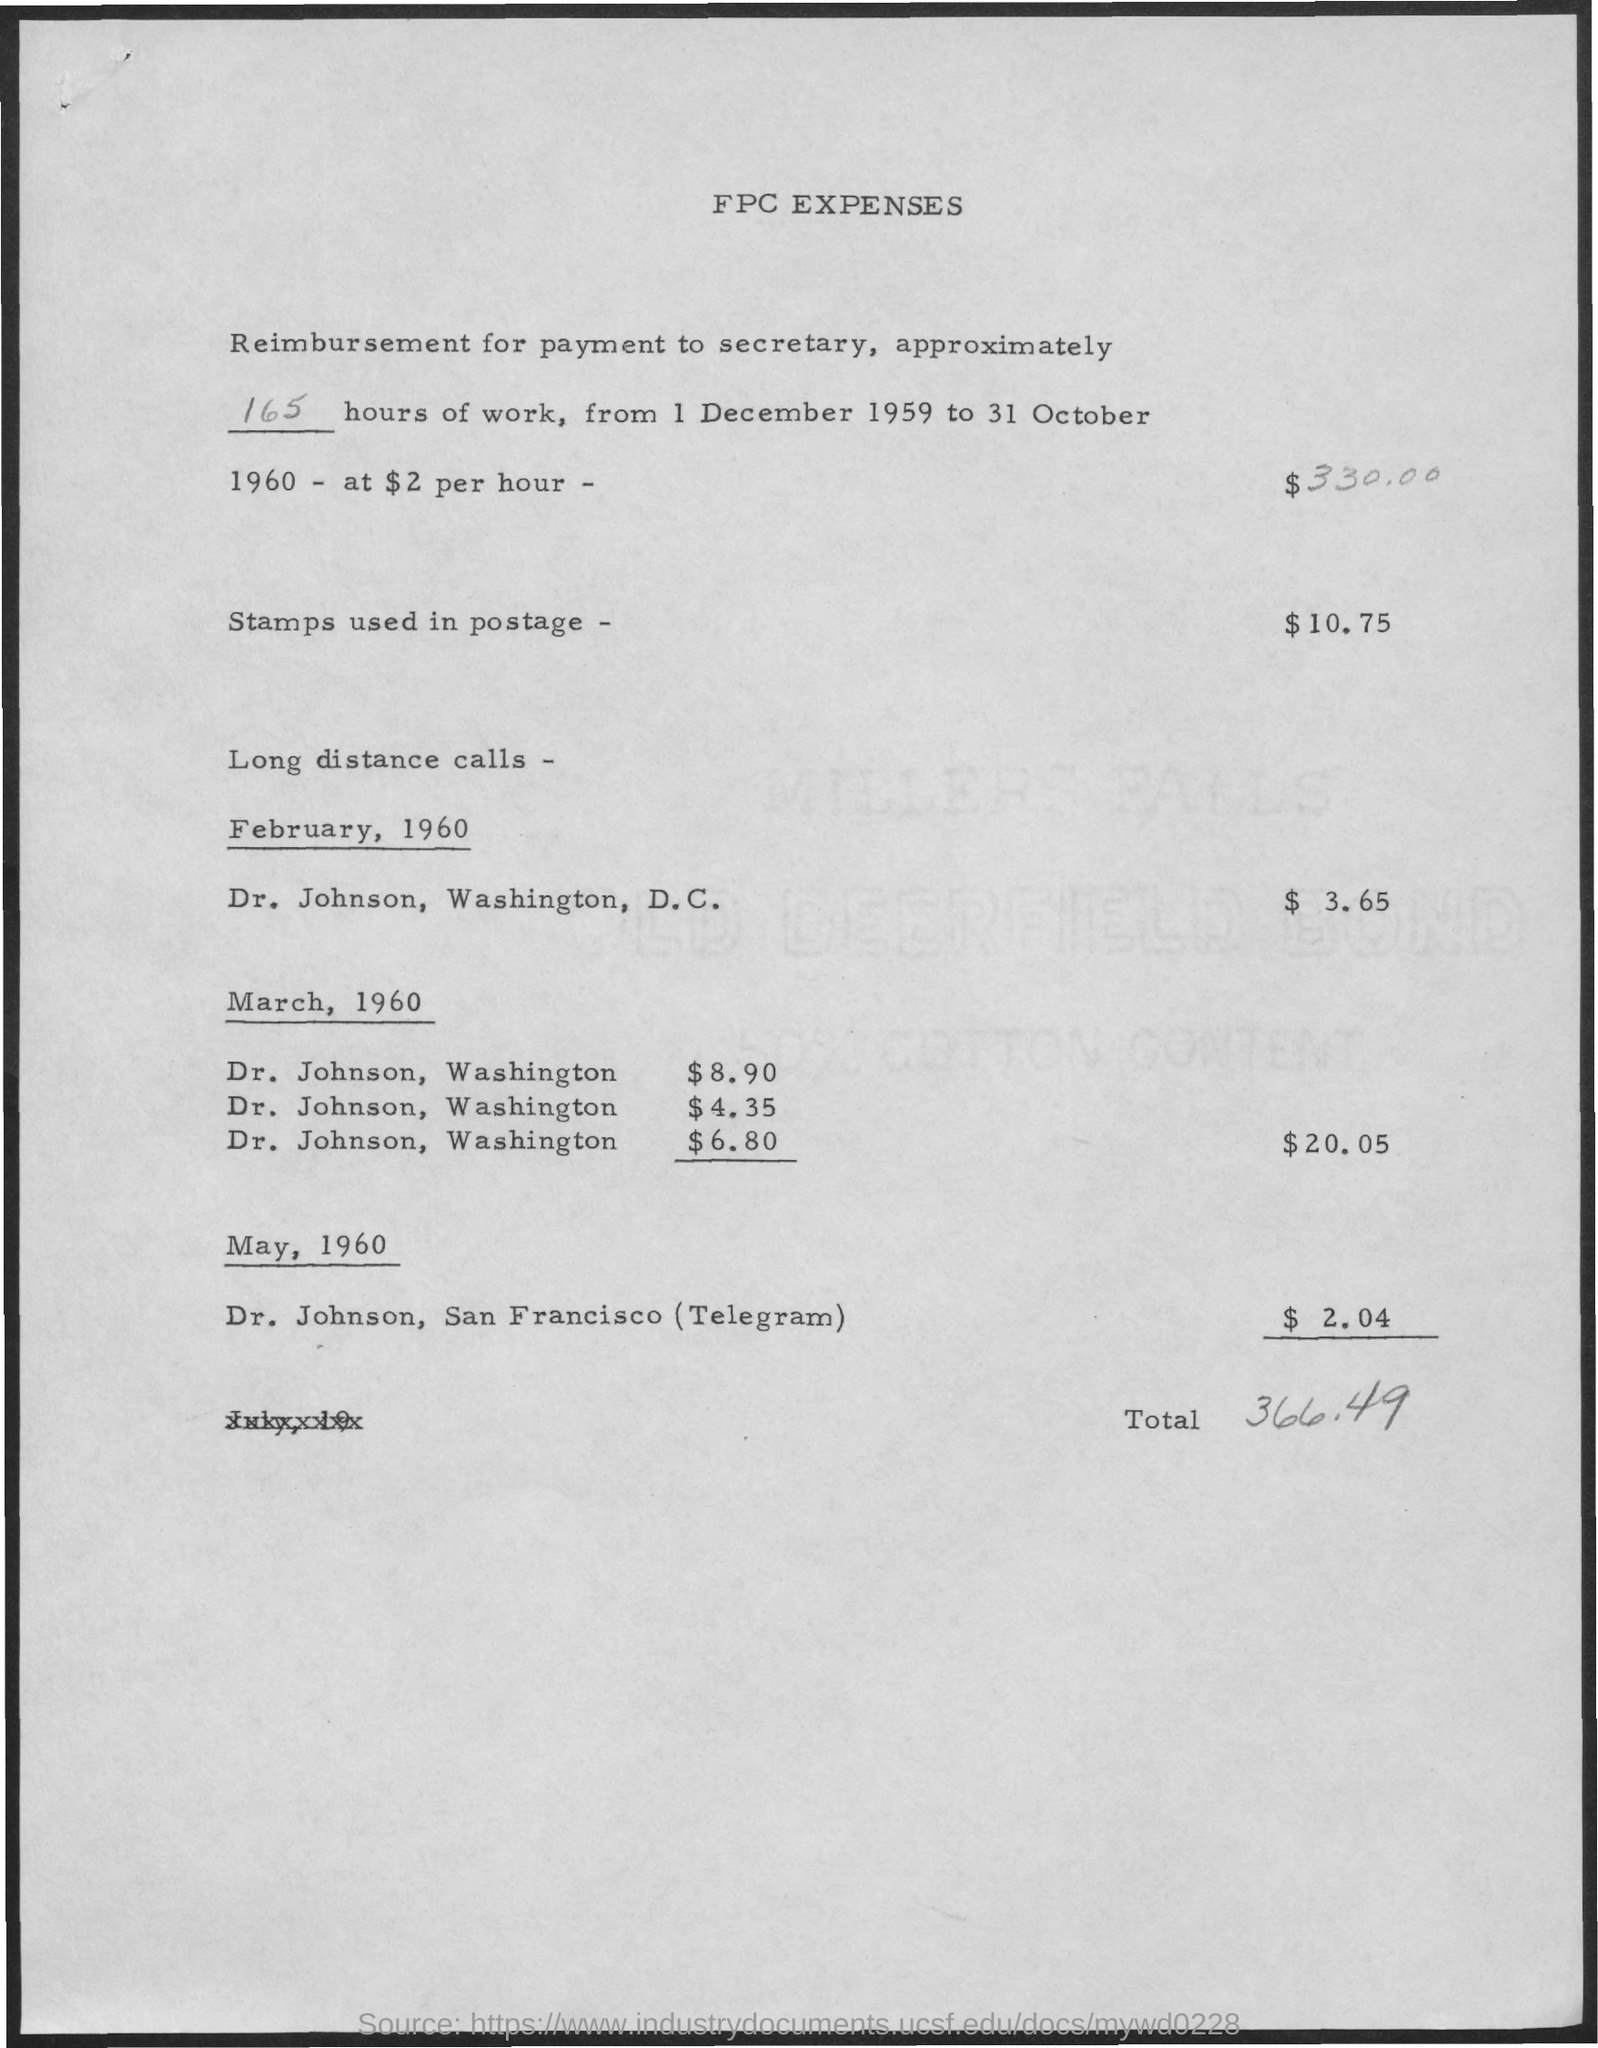What is the heading of the data ?
Ensure brevity in your answer.  FPC EXPENSES. What is the amount of payment to be made to secretary, for 165 hours of work?
Give a very brief answer. $330.00. What is the amount related to stamps used in postage?
Provide a succinct answer. $ 10.75. What are charges for long distance calls on february, 1960?
Your response must be concise. $ 3.65. What are charges in total for long distance calls on march, 1960?
Provide a short and direct response. $ 20.05. What is the charge for telegram to dr. johnson, san francisco?
Provide a succinct answer. $ 2.04. What is the total amount of fpc expenses?
Provide a succinct answer. 366.49. 